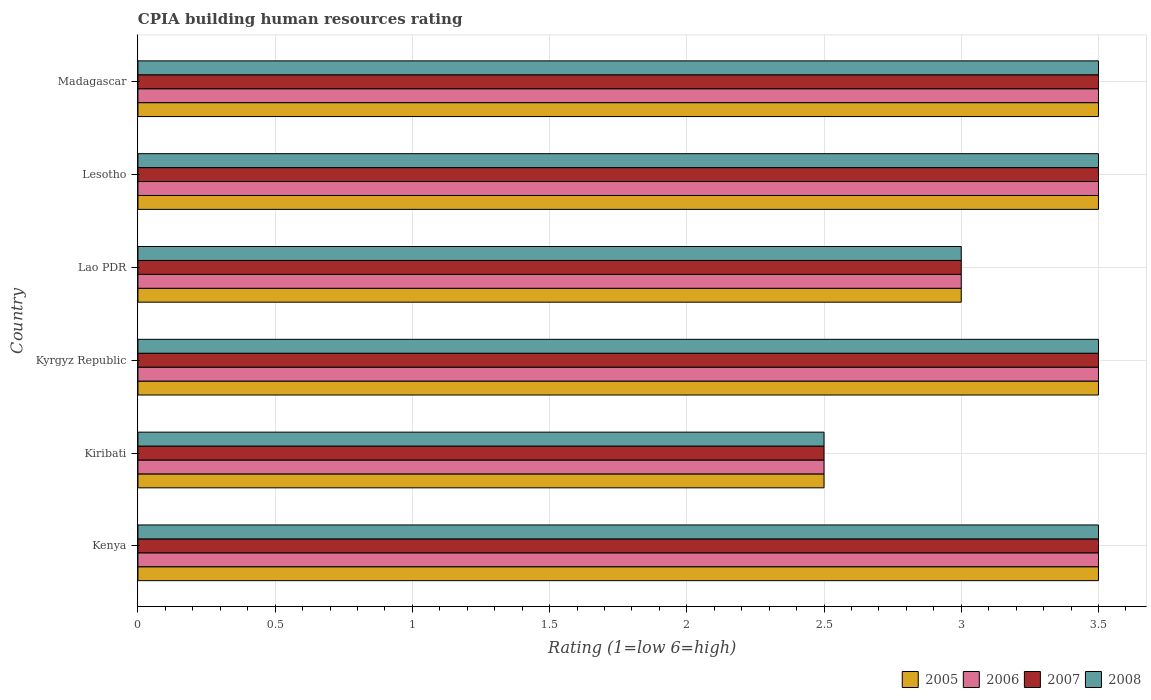How many different coloured bars are there?
Ensure brevity in your answer.  4. How many groups of bars are there?
Offer a terse response. 6. What is the label of the 4th group of bars from the top?
Your answer should be compact. Kyrgyz Republic. In which country was the CPIA rating in 2006 maximum?
Your answer should be compact. Kenya. In which country was the CPIA rating in 2008 minimum?
Make the answer very short. Kiribati. What is the total CPIA rating in 2006 in the graph?
Give a very brief answer. 19.5. What is the difference between the CPIA rating in 2007 in Kenya and that in Kiribati?
Keep it short and to the point. 1. What is the difference between the CPIA rating in 2005 in Lesotho and the CPIA rating in 2006 in Madagascar?
Offer a very short reply. 0. What is the difference between the CPIA rating in 2005 and CPIA rating in 2007 in Kenya?
Give a very brief answer. 0. In how many countries, is the CPIA rating in 2006 greater than 3.2 ?
Make the answer very short. 4. What is the ratio of the CPIA rating in 2006 in Kenya to that in Kiribati?
Provide a short and direct response. 1.4. Is the CPIA rating in 2006 in Kenya less than that in Madagascar?
Your answer should be compact. No. What is the difference between the highest and the lowest CPIA rating in 2007?
Keep it short and to the point. 1. Is the sum of the CPIA rating in 2008 in Kyrgyz Republic and Lesotho greater than the maximum CPIA rating in 2005 across all countries?
Your answer should be compact. Yes. Is it the case that in every country, the sum of the CPIA rating in 2006 and CPIA rating in 2005 is greater than the sum of CPIA rating in 2007 and CPIA rating in 2008?
Make the answer very short. No. What does the 1st bar from the top in Kiribati represents?
Ensure brevity in your answer.  2008. What does the 1st bar from the bottom in Kyrgyz Republic represents?
Keep it short and to the point. 2005. How many bars are there?
Ensure brevity in your answer.  24. How many countries are there in the graph?
Offer a very short reply. 6. Are the values on the major ticks of X-axis written in scientific E-notation?
Offer a terse response. No. Does the graph contain grids?
Provide a short and direct response. Yes. Where does the legend appear in the graph?
Your answer should be very brief. Bottom right. How many legend labels are there?
Provide a succinct answer. 4. What is the title of the graph?
Give a very brief answer. CPIA building human resources rating. Does "1978" appear as one of the legend labels in the graph?
Make the answer very short. No. What is the label or title of the X-axis?
Offer a very short reply. Rating (1=low 6=high). What is the label or title of the Y-axis?
Provide a succinct answer. Country. What is the Rating (1=low 6=high) in 2006 in Kenya?
Your answer should be compact. 3.5. What is the Rating (1=low 6=high) in 2005 in Kiribati?
Ensure brevity in your answer.  2.5. What is the Rating (1=low 6=high) in 2005 in Kyrgyz Republic?
Provide a short and direct response. 3.5. What is the Rating (1=low 6=high) of 2007 in Kyrgyz Republic?
Ensure brevity in your answer.  3.5. What is the Rating (1=low 6=high) of 2005 in Lao PDR?
Offer a very short reply. 3. What is the Rating (1=low 6=high) of 2007 in Lao PDR?
Keep it short and to the point. 3. What is the Rating (1=low 6=high) in 2005 in Lesotho?
Make the answer very short. 3.5. What is the Rating (1=low 6=high) of 2008 in Lesotho?
Offer a very short reply. 3.5. What is the Rating (1=low 6=high) of 2007 in Madagascar?
Give a very brief answer. 3.5. Across all countries, what is the maximum Rating (1=low 6=high) in 2005?
Make the answer very short. 3.5. Across all countries, what is the maximum Rating (1=low 6=high) of 2006?
Offer a terse response. 3.5. Across all countries, what is the maximum Rating (1=low 6=high) in 2008?
Provide a succinct answer. 3.5. Across all countries, what is the minimum Rating (1=low 6=high) in 2005?
Your response must be concise. 2.5. Across all countries, what is the minimum Rating (1=low 6=high) in 2006?
Ensure brevity in your answer.  2.5. What is the total Rating (1=low 6=high) of 2005 in the graph?
Offer a terse response. 19.5. What is the total Rating (1=low 6=high) in 2007 in the graph?
Give a very brief answer. 19.5. What is the total Rating (1=low 6=high) of 2008 in the graph?
Your answer should be very brief. 19.5. What is the difference between the Rating (1=low 6=high) of 2005 in Kenya and that in Kiribati?
Give a very brief answer. 1. What is the difference between the Rating (1=low 6=high) of 2005 in Kenya and that in Kyrgyz Republic?
Ensure brevity in your answer.  0. What is the difference between the Rating (1=low 6=high) of 2006 in Kenya and that in Kyrgyz Republic?
Your answer should be very brief. 0. What is the difference between the Rating (1=low 6=high) in 2005 in Kenya and that in Lesotho?
Give a very brief answer. 0. What is the difference between the Rating (1=low 6=high) of 2006 in Kenya and that in Lesotho?
Provide a succinct answer. 0. What is the difference between the Rating (1=low 6=high) in 2007 in Kenya and that in Lesotho?
Your answer should be very brief. 0. What is the difference between the Rating (1=low 6=high) of 2008 in Kenya and that in Lesotho?
Make the answer very short. 0. What is the difference between the Rating (1=low 6=high) in 2008 in Kiribati and that in Kyrgyz Republic?
Give a very brief answer. -1. What is the difference between the Rating (1=low 6=high) in 2005 in Kiribati and that in Lao PDR?
Give a very brief answer. -0.5. What is the difference between the Rating (1=low 6=high) of 2006 in Kiribati and that in Lao PDR?
Your answer should be compact. -0.5. What is the difference between the Rating (1=low 6=high) in 2007 in Kiribati and that in Lao PDR?
Offer a very short reply. -0.5. What is the difference between the Rating (1=low 6=high) of 2008 in Kiribati and that in Lao PDR?
Offer a terse response. -0.5. What is the difference between the Rating (1=low 6=high) of 2008 in Kiribati and that in Lesotho?
Provide a succinct answer. -1. What is the difference between the Rating (1=low 6=high) in 2008 in Kiribati and that in Madagascar?
Ensure brevity in your answer.  -1. What is the difference between the Rating (1=low 6=high) of 2005 in Kyrgyz Republic and that in Lao PDR?
Offer a very short reply. 0.5. What is the difference between the Rating (1=low 6=high) of 2008 in Kyrgyz Republic and that in Lao PDR?
Give a very brief answer. 0.5. What is the difference between the Rating (1=low 6=high) in 2006 in Kyrgyz Republic and that in Lesotho?
Provide a short and direct response. 0. What is the difference between the Rating (1=low 6=high) of 2007 in Kyrgyz Republic and that in Lesotho?
Ensure brevity in your answer.  0. What is the difference between the Rating (1=low 6=high) in 2005 in Kyrgyz Republic and that in Madagascar?
Offer a terse response. 0. What is the difference between the Rating (1=low 6=high) in 2006 in Kyrgyz Republic and that in Madagascar?
Make the answer very short. 0. What is the difference between the Rating (1=low 6=high) in 2007 in Kyrgyz Republic and that in Madagascar?
Your answer should be compact. 0. What is the difference between the Rating (1=low 6=high) in 2005 in Lao PDR and that in Lesotho?
Provide a short and direct response. -0.5. What is the difference between the Rating (1=low 6=high) in 2006 in Lao PDR and that in Lesotho?
Provide a short and direct response. -0.5. What is the difference between the Rating (1=low 6=high) of 2007 in Lao PDR and that in Lesotho?
Make the answer very short. -0.5. What is the difference between the Rating (1=low 6=high) in 2008 in Lao PDR and that in Lesotho?
Your response must be concise. -0.5. What is the difference between the Rating (1=low 6=high) of 2005 in Lao PDR and that in Madagascar?
Your response must be concise. -0.5. What is the difference between the Rating (1=low 6=high) of 2006 in Lao PDR and that in Madagascar?
Make the answer very short. -0.5. What is the difference between the Rating (1=low 6=high) in 2008 in Lao PDR and that in Madagascar?
Provide a short and direct response. -0.5. What is the difference between the Rating (1=low 6=high) in 2006 in Lesotho and that in Madagascar?
Provide a succinct answer. 0. What is the difference between the Rating (1=low 6=high) of 2008 in Lesotho and that in Madagascar?
Your answer should be very brief. 0. What is the difference between the Rating (1=low 6=high) of 2005 in Kenya and the Rating (1=low 6=high) of 2006 in Kiribati?
Provide a succinct answer. 1. What is the difference between the Rating (1=low 6=high) in 2005 in Kenya and the Rating (1=low 6=high) in 2007 in Kiribati?
Provide a succinct answer. 1. What is the difference between the Rating (1=low 6=high) of 2005 in Kenya and the Rating (1=low 6=high) of 2008 in Kiribati?
Make the answer very short. 1. What is the difference between the Rating (1=low 6=high) of 2006 in Kenya and the Rating (1=low 6=high) of 2007 in Kiribati?
Your answer should be very brief. 1. What is the difference between the Rating (1=low 6=high) of 2007 in Kenya and the Rating (1=low 6=high) of 2008 in Kiribati?
Keep it short and to the point. 1. What is the difference between the Rating (1=low 6=high) in 2005 in Kenya and the Rating (1=low 6=high) in 2006 in Kyrgyz Republic?
Your answer should be compact. 0. What is the difference between the Rating (1=low 6=high) of 2005 in Kenya and the Rating (1=low 6=high) of 2008 in Kyrgyz Republic?
Keep it short and to the point. 0. What is the difference between the Rating (1=low 6=high) of 2006 in Kenya and the Rating (1=low 6=high) of 2008 in Kyrgyz Republic?
Your response must be concise. 0. What is the difference between the Rating (1=low 6=high) of 2007 in Kenya and the Rating (1=low 6=high) of 2008 in Kyrgyz Republic?
Provide a succinct answer. 0. What is the difference between the Rating (1=low 6=high) of 2005 in Kenya and the Rating (1=low 6=high) of 2008 in Lao PDR?
Ensure brevity in your answer.  0.5. What is the difference between the Rating (1=low 6=high) in 2006 in Kenya and the Rating (1=low 6=high) in 2008 in Lao PDR?
Make the answer very short. 0.5. What is the difference between the Rating (1=low 6=high) of 2007 in Kenya and the Rating (1=low 6=high) of 2008 in Lao PDR?
Make the answer very short. 0.5. What is the difference between the Rating (1=low 6=high) of 2007 in Kenya and the Rating (1=low 6=high) of 2008 in Lesotho?
Your answer should be compact. 0. What is the difference between the Rating (1=low 6=high) of 2005 in Kenya and the Rating (1=low 6=high) of 2006 in Madagascar?
Provide a succinct answer. 0. What is the difference between the Rating (1=low 6=high) of 2005 in Kenya and the Rating (1=low 6=high) of 2008 in Madagascar?
Your response must be concise. 0. What is the difference between the Rating (1=low 6=high) in 2006 in Kenya and the Rating (1=low 6=high) in 2007 in Madagascar?
Make the answer very short. 0. What is the difference between the Rating (1=low 6=high) of 2005 in Kiribati and the Rating (1=low 6=high) of 2006 in Kyrgyz Republic?
Offer a very short reply. -1. What is the difference between the Rating (1=low 6=high) in 2005 in Kiribati and the Rating (1=low 6=high) in 2007 in Kyrgyz Republic?
Keep it short and to the point. -1. What is the difference between the Rating (1=low 6=high) in 2005 in Kiribati and the Rating (1=low 6=high) in 2008 in Kyrgyz Republic?
Provide a short and direct response. -1. What is the difference between the Rating (1=low 6=high) in 2005 in Kiribati and the Rating (1=low 6=high) in 2006 in Lao PDR?
Give a very brief answer. -0.5. What is the difference between the Rating (1=low 6=high) of 2005 in Kiribati and the Rating (1=low 6=high) of 2007 in Lao PDR?
Your answer should be compact. -0.5. What is the difference between the Rating (1=low 6=high) of 2005 in Kiribati and the Rating (1=low 6=high) of 2007 in Lesotho?
Your answer should be very brief. -1. What is the difference between the Rating (1=low 6=high) in 2005 in Kiribati and the Rating (1=low 6=high) in 2008 in Lesotho?
Provide a succinct answer. -1. What is the difference between the Rating (1=low 6=high) in 2006 in Kiribati and the Rating (1=low 6=high) in 2007 in Lesotho?
Ensure brevity in your answer.  -1. What is the difference between the Rating (1=low 6=high) of 2007 in Kiribati and the Rating (1=low 6=high) of 2008 in Lesotho?
Provide a succinct answer. -1. What is the difference between the Rating (1=low 6=high) in 2006 in Kiribati and the Rating (1=low 6=high) in 2007 in Madagascar?
Keep it short and to the point. -1. What is the difference between the Rating (1=low 6=high) of 2006 in Kiribati and the Rating (1=low 6=high) of 2008 in Madagascar?
Ensure brevity in your answer.  -1. What is the difference between the Rating (1=low 6=high) of 2005 in Kyrgyz Republic and the Rating (1=low 6=high) of 2006 in Lao PDR?
Your answer should be compact. 0.5. What is the difference between the Rating (1=low 6=high) of 2005 in Kyrgyz Republic and the Rating (1=low 6=high) of 2007 in Lao PDR?
Your response must be concise. 0.5. What is the difference between the Rating (1=low 6=high) of 2005 in Kyrgyz Republic and the Rating (1=low 6=high) of 2008 in Lao PDR?
Provide a short and direct response. 0.5. What is the difference between the Rating (1=low 6=high) in 2007 in Kyrgyz Republic and the Rating (1=low 6=high) in 2008 in Lao PDR?
Offer a very short reply. 0.5. What is the difference between the Rating (1=low 6=high) of 2005 in Kyrgyz Republic and the Rating (1=low 6=high) of 2006 in Lesotho?
Ensure brevity in your answer.  0. What is the difference between the Rating (1=low 6=high) in 2005 in Kyrgyz Republic and the Rating (1=low 6=high) in 2007 in Lesotho?
Offer a terse response. 0. What is the difference between the Rating (1=low 6=high) in 2006 in Kyrgyz Republic and the Rating (1=low 6=high) in 2007 in Lesotho?
Give a very brief answer. 0. What is the difference between the Rating (1=low 6=high) in 2006 in Kyrgyz Republic and the Rating (1=low 6=high) in 2008 in Lesotho?
Give a very brief answer. 0. What is the difference between the Rating (1=low 6=high) of 2007 in Kyrgyz Republic and the Rating (1=low 6=high) of 2008 in Lesotho?
Your answer should be very brief. 0. What is the difference between the Rating (1=low 6=high) in 2005 in Kyrgyz Republic and the Rating (1=low 6=high) in 2006 in Madagascar?
Offer a terse response. 0. What is the difference between the Rating (1=low 6=high) of 2005 in Kyrgyz Republic and the Rating (1=low 6=high) of 2008 in Madagascar?
Provide a short and direct response. 0. What is the difference between the Rating (1=low 6=high) in 2005 in Lao PDR and the Rating (1=low 6=high) in 2007 in Lesotho?
Your response must be concise. -0.5. What is the difference between the Rating (1=low 6=high) of 2005 in Lao PDR and the Rating (1=low 6=high) of 2008 in Madagascar?
Your response must be concise. -0.5. What is the difference between the Rating (1=low 6=high) of 2005 in Lesotho and the Rating (1=low 6=high) of 2006 in Madagascar?
Provide a succinct answer. 0. What is the difference between the Rating (1=low 6=high) of 2005 in Lesotho and the Rating (1=low 6=high) of 2007 in Madagascar?
Ensure brevity in your answer.  0. What is the difference between the Rating (1=low 6=high) of 2006 in Lesotho and the Rating (1=low 6=high) of 2007 in Madagascar?
Keep it short and to the point. 0. What is the difference between the Rating (1=low 6=high) in 2007 in Lesotho and the Rating (1=low 6=high) in 2008 in Madagascar?
Ensure brevity in your answer.  0. What is the average Rating (1=low 6=high) in 2005 per country?
Your response must be concise. 3.25. What is the average Rating (1=low 6=high) of 2006 per country?
Your answer should be very brief. 3.25. What is the difference between the Rating (1=low 6=high) in 2005 and Rating (1=low 6=high) in 2008 in Kenya?
Make the answer very short. 0. What is the difference between the Rating (1=low 6=high) in 2006 and Rating (1=low 6=high) in 2007 in Kenya?
Keep it short and to the point. 0. What is the difference between the Rating (1=low 6=high) in 2007 and Rating (1=low 6=high) in 2008 in Kenya?
Your response must be concise. 0. What is the difference between the Rating (1=low 6=high) in 2005 and Rating (1=low 6=high) in 2006 in Kiribati?
Provide a succinct answer. 0. What is the difference between the Rating (1=low 6=high) of 2005 and Rating (1=low 6=high) of 2007 in Kiribati?
Provide a succinct answer. 0. What is the difference between the Rating (1=low 6=high) in 2005 and Rating (1=low 6=high) in 2006 in Kyrgyz Republic?
Provide a short and direct response. 0. What is the difference between the Rating (1=low 6=high) in 2005 and Rating (1=low 6=high) in 2007 in Kyrgyz Republic?
Offer a terse response. 0. What is the difference between the Rating (1=low 6=high) of 2006 and Rating (1=low 6=high) of 2007 in Kyrgyz Republic?
Give a very brief answer. 0. What is the difference between the Rating (1=low 6=high) in 2005 and Rating (1=low 6=high) in 2006 in Lao PDR?
Make the answer very short. 0. What is the difference between the Rating (1=low 6=high) in 2005 and Rating (1=low 6=high) in 2007 in Lao PDR?
Provide a short and direct response. 0. What is the difference between the Rating (1=low 6=high) in 2005 and Rating (1=low 6=high) in 2008 in Lao PDR?
Offer a terse response. 0. What is the difference between the Rating (1=low 6=high) in 2005 and Rating (1=low 6=high) in 2008 in Lesotho?
Give a very brief answer. 0. What is the difference between the Rating (1=low 6=high) of 2006 and Rating (1=low 6=high) of 2007 in Lesotho?
Your answer should be compact. 0. What is the difference between the Rating (1=low 6=high) of 2007 and Rating (1=low 6=high) of 2008 in Lesotho?
Give a very brief answer. 0. What is the difference between the Rating (1=low 6=high) in 2005 and Rating (1=low 6=high) in 2006 in Madagascar?
Make the answer very short. 0. What is the difference between the Rating (1=low 6=high) in 2005 and Rating (1=low 6=high) in 2008 in Madagascar?
Provide a succinct answer. 0. What is the difference between the Rating (1=low 6=high) in 2006 and Rating (1=low 6=high) in 2007 in Madagascar?
Keep it short and to the point. 0. What is the difference between the Rating (1=low 6=high) of 2007 and Rating (1=low 6=high) of 2008 in Madagascar?
Your answer should be very brief. 0. What is the ratio of the Rating (1=low 6=high) in 2008 in Kenya to that in Kiribati?
Your answer should be very brief. 1.4. What is the ratio of the Rating (1=low 6=high) in 2005 in Kenya to that in Kyrgyz Republic?
Give a very brief answer. 1. What is the ratio of the Rating (1=low 6=high) of 2006 in Kenya to that in Kyrgyz Republic?
Your response must be concise. 1. What is the ratio of the Rating (1=low 6=high) of 2007 in Kenya to that in Kyrgyz Republic?
Your response must be concise. 1. What is the ratio of the Rating (1=low 6=high) in 2005 in Kenya to that in Lao PDR?
Offer a terse response. 1.17. What is the ratio of the Rating (1=low 6=high) of 2008 in Kenya to that in Lao PDR?
Your response must be concise. 1.17. What is the ratio of the Rating (1=low 6=high) of 2005 in Kenya to that in Lesotho?
Provide a short and direct response. 1. What is the ratio of the Rating (1=low 6=high) of 2007 in Kenya to that in Lesotho?
Your answer should be very brief. 1. What is the ratio of the Rating (1=low 6=high) in 2008 in Kenya to that in Lesotho?
Your answer should be very brief. 1. What is the ratio of the Rating (1=low 6=high) of 2005 in Kenya to that in Madagascar?
Give a very brief answer. 1. What is the ratio of the Rating (1=low 6=high) in 2008 in Kenya to that in Madagascar?
Provide a succinct answer. 1. What is the ratio of the Rating (1=low 6=high) of 2006 in Kiribati to that in Kyrgyz Republic?
Your response must be concise. 0.71. What is the ratio of the Rating (1=low 6=high) of 2005 in Kiribati to that in Lao PDR?
Your answer should be compact. 0.83. What is the ratio of the Rating (1=low 6=high) in 2007 in Kiribati to that in Lao PDR?
Ensure brevity in your answer.  0.83. What is the ratio of the Rating (1=low 6=high) of 2008 in Kiribati to that in Lao PDR?
Offer a terse response. 0.83. What is the ratio of the Rating (1=low 6=high) in 2005 in Kiribati to that in Lesotho?
Provide a succinct answer. 0.71. What is the ratio of the Rating (1=low 6=high) of 2007 in Kiribati to that in Lesotho?
Give a very brief answer. 0.71. What is the ratio of the Rating (1=low 6=high) in 2005 in Kiribati to that in Madagascar?
Provide a succinct answer. 0.71. What is the ratio of the Rating (1=low 6=high) of 2007 in Kiribati to that in Madagascar?
Give a very brief answer. 0.71. What is the ratio of the Rating (1=low 6=high) in 2008 in Kiribati to that in Madagascar?
Give a very brief answer. 0.71. What is the ratio of the Rating (1=low 6=high) of 2005 in Kyrgyz Republic to that in Lao PDR?
Provide a succinct answer. 1.17. What is the ratio of the Rating (1=low 6=high) of 2006 in Kyrgyz Republic to that in Lao PDR?
Offer a terse response. 1.17. What is the ratio of the Rating (1=low 6=high) in 2007 in Kyrgyz Republic to that in Lao PDR?
Your response must be concise. 1.17. What is the ratio of the Rating (1=low 6=high) in 2005 in Kyrgyz Republic to that in Lesotho?
Provide a short and direct response. 1. What is the ratio of the Rating (1=low 6=high) of 2006 in Kyrgyz Republic to that in Lesotho?
Your answer should be compact. 1. What is the ratio of the Rating (1=low 6=high) of 2007 in Kyrgyz Republic to that in Lesotho?
Provide a succinct answer. 1. What is the ratio of the Rating (1=low 6=high) of 2005 in Kyrgyz Republic to that in Madagascar?
Your answer should be compact. 1. What is the ratio of the Rating (1=low 6=high) of 2006 in Kyrgyz Republic to that in Madagascar?
Your answer should be compact. 1. What is the ratio of the Rating (1=low 6=high) in 2007 in Kyrgyz Republic to that in Madagascar?
Your answer should be very brief. 1. What is the ratio of the Rating (1=low 6=high) in 2008 in Kyrgyz Republic to that in Madagascar?
Your response must be concise. 1. What is the ratio of the Rating (1=low 6=high) in 2005 in Lao PDR to that in Lesotho?
Provide a short and direct response. 0.86. What is the ratio of the Rating (1=low 6=high) of 2007 in Lao PDR to that in Lesotho?
Your answer should be compact. 0.86. What is the ratio of the Rating (1=low 6=high) in 2005 in Lao PDR to that in Madagascar?
Make the answer very short. 0.86. What is the ratio of the Rating (1=low 6=high) in 2006 in Lesotho to that in Madagascar?
Your answer should be very brief. 1. What is the difference between the highest and the second highest Rating (1=low 6=high) of 2005?
Your answer should be very brief. 0. What is the difference between the highest and the second highest Rating (1=low 6=high) in 2006?
Keep it short and to the point. 0. 